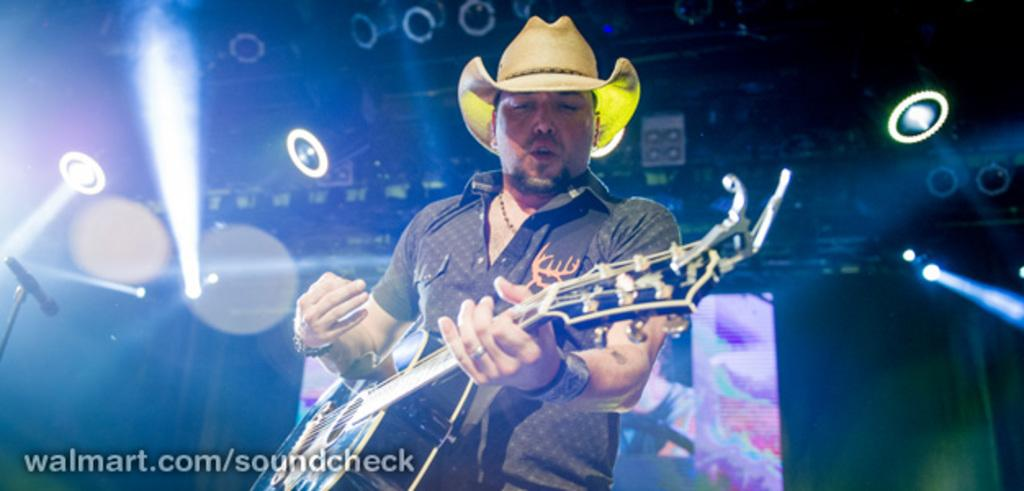What is the main subject of the image? There is a person in the image. What is the person doing in the image? The person is standing and holding a guitar. What can be seen in the background of the image? There are lights and a microphone in the background of the image. How many trees are visible in the image? There are no trees visible in the image. What is the weight of the dolls in the image? There are no dolls present in the image, so their weight cannot be determined. 